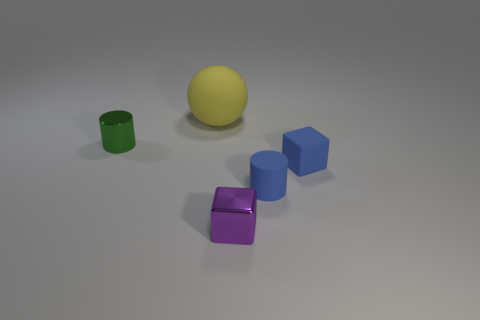Add 4 large matte balls. How many objects exist? 9 Subtract all cubes. How many objects are left? 3 Add 3 yellow things. How many yellow things are left? 4 Add 2 big red metal balls. How many big red metal balls exist? 2 Subtract 0 gray blocks. How many objects are left? 5 Subtract all tiny blue cubes. Subtract all small purple objects. How many objects are left? 3 